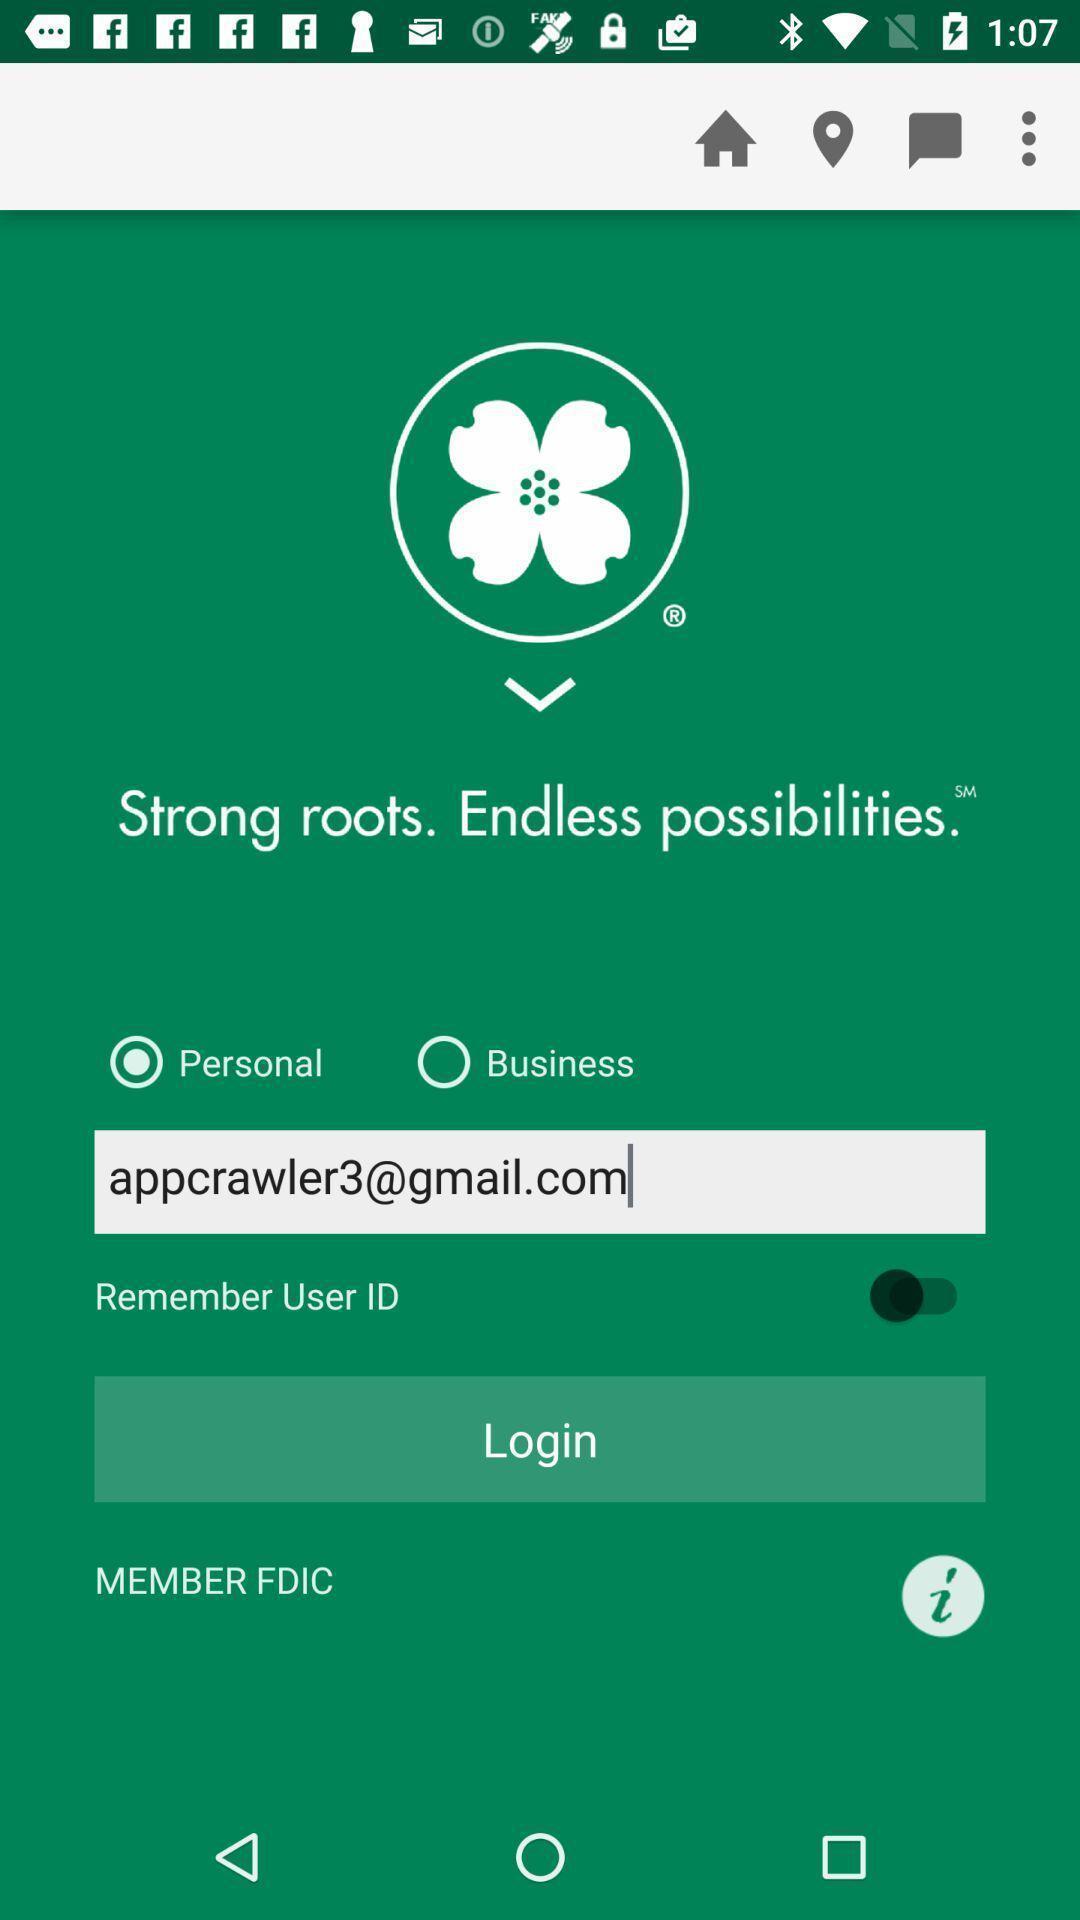Summarize the information in this screenshot. Page showing information of sign up. 